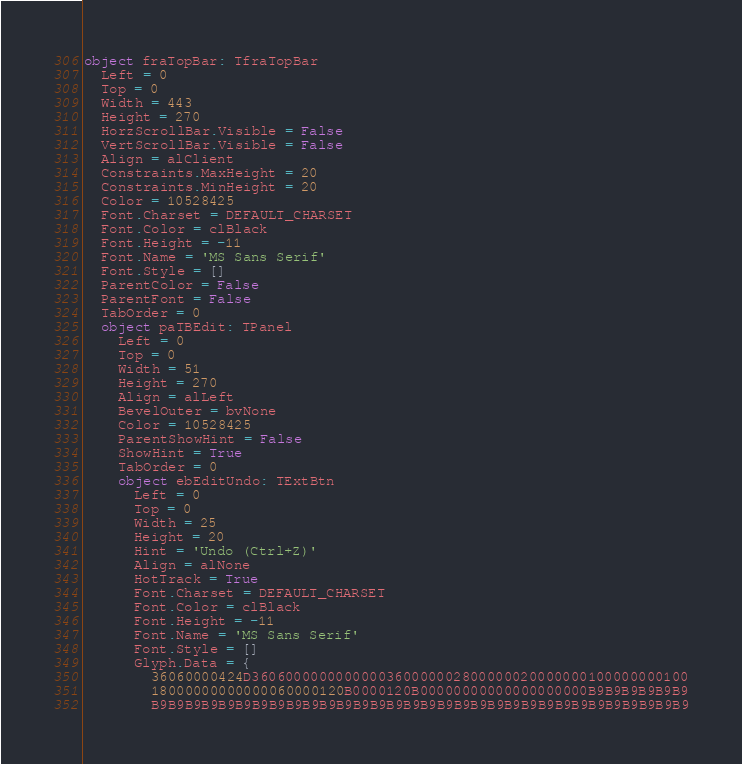Convert code to text. <code><loc_0><loc_0><loc_500><loc_500><_Pascal_>object fraTopBar: TfraTopBar
  Left = 0
  Top = 0
  Width = 443
  Height = 270
  HorzScrollBar.Visible = False
  VertScrollBar.Visible = False
  Align = alClient
  Constraints.MaxHeight = 20
  Constraints.MinHeight = 20
  Color = 10528425
  Font.Charset = DEFAULT_CHARSET
  Font.Color = clBlack
  Font.Height = -11
  Font.Name = 'MS Sans Serif'
  Font.Style = []
  ParentColor = False
  ParentFont = False
  TabOrder = 0
  object paTBEdit: TPanel
    Left = 0
    Top = 0
    Width = 51
    Height = 270
    Align = alLeft
    BevelOuter = bvNone
    Color = 10528425
    ParentShowHint = False
    ShowHint = True
    TabOrder = 0
    object ebEditUndo: TExtBtn
      Left = 0
      Top = 0
      Width = 25
      Height = 20
      Hint = 'Undo (Ctrl+Z)'
      Align = alNone
      HotTrack = True
      Font.Charset = DEFAULT_CHARSET
      Font.Color = clBlack
      Font.Height = -11
      Font.Name = 'MS Sans Serif'
      Font.Style = []
      Glyph.Data = {
        36060000424D3606000000000000360000002800000020000000100000000100
        18000000000000060000120B0000120B00000000000000000000B9B9B9B9B9B9
        B9B9B9B9B9B9B9B9B9B9B9B9B9B9B9B9B9B9B9B9B9B9B9B9B9B9B9B9B9B9B9B9</code> 